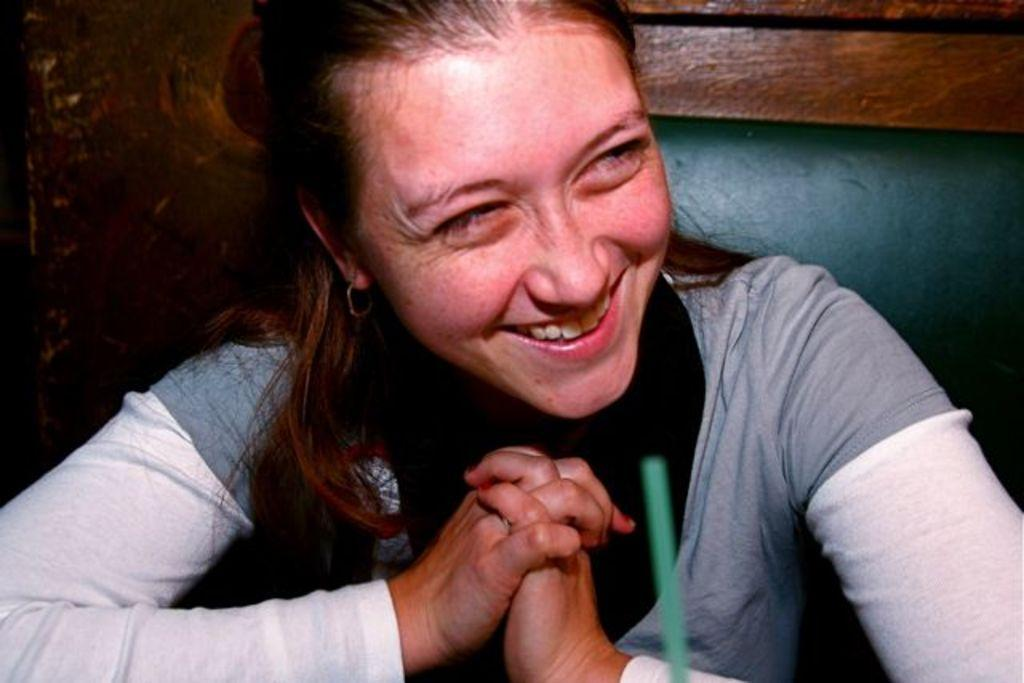Who is the main subject in the foreground of the image? There is a woman in the foreground of the image. What is the woman doing in the image? The woman is sitting and laughing. What can be seen behind the woman? There is a green chair-like object behind the woman. What type of wall is visible in the background? There is a wooden wall in the background. What is the woman's belief about the expert's opinion on the home renovation project? There is no information about the woman's beliefs, an expert, or a home renovation project in the image. 